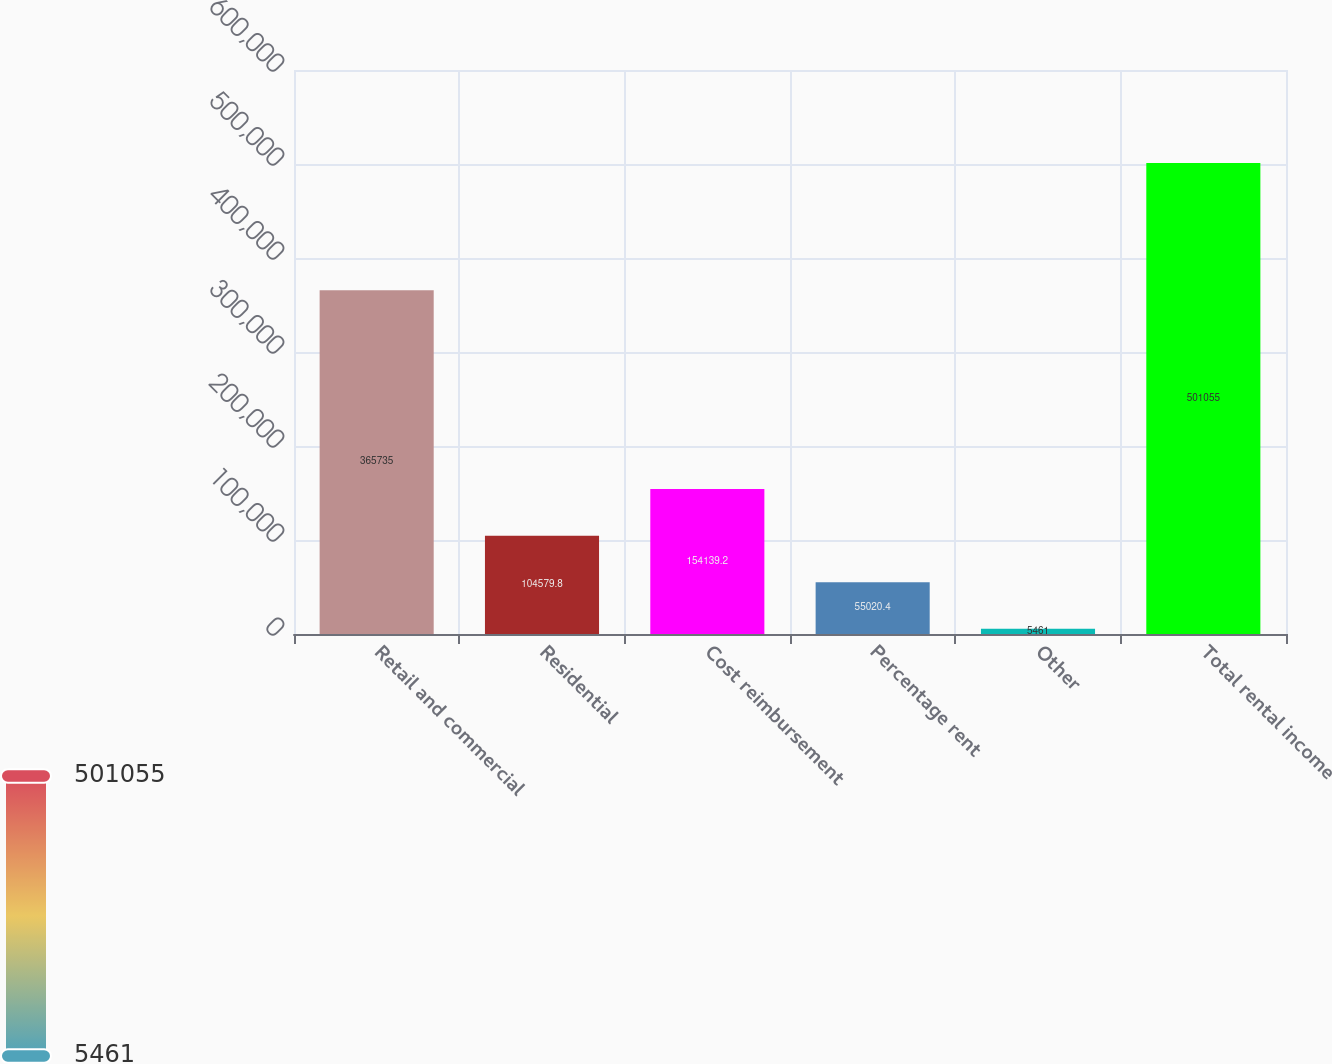Convert chart. <chart><loc_0><loc_0><loc_500><loc_500><bar_chart><fcel>Retail and commercial<fcel>Residential<fcel>Cost reimbursement<fcel>Percentage rent<fcel>Other<fcel>Total rental income<nl><fcel>365735<fcel>104580<fcel>154139<fcel>55020.4<fcel>5461<fcel>501055<nl></chart> 